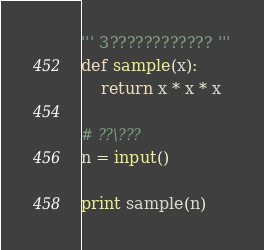<code> <loc_0><loc_0><loc_500><loc_500><_Python_>''' 3???????????? '''
def sample(x):
    return x * x * x 

# ??\???
n = input()

print sample(n)</code> 